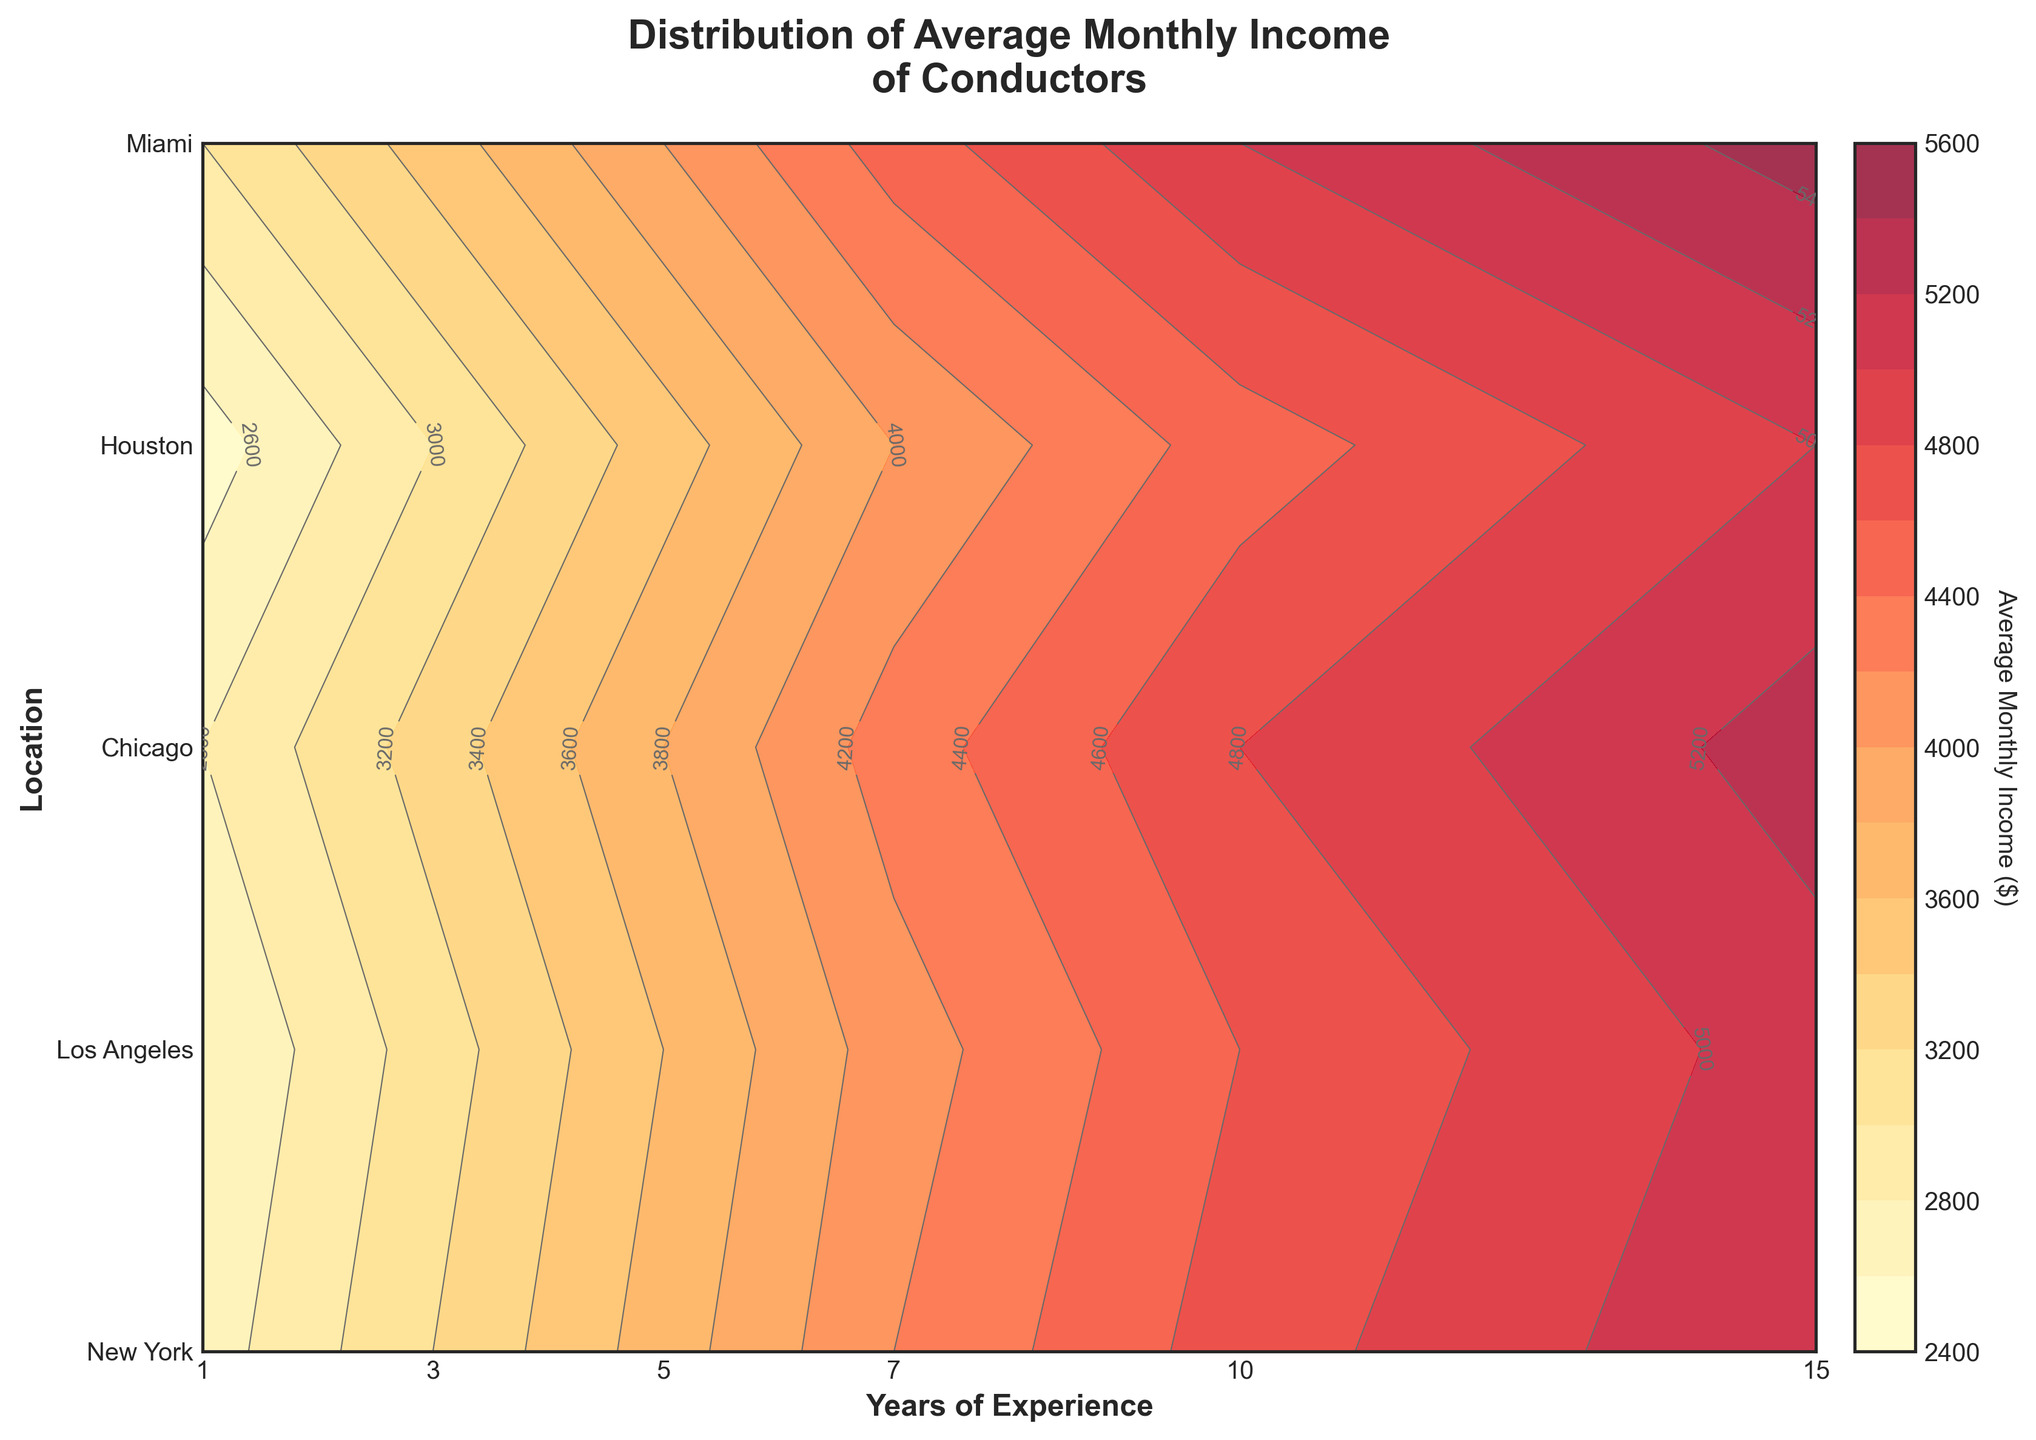What's the title of the plot? The title of the plot is usually located at the top of the figure and contains the main subject of the data being presented. This one is labeled "Distribution of Average Monthly Income of Conductors".
Answer: Distribution of Average Monthly Income of Conductors Which location has the highest average monthly income for conductors with 10 years of experience? From the figure, we can look at the contour labels for the 10-year mark and identify the highest income value among the locations listed. New York has the highest value at this level of experience.
Answer: New York What is the approximate average monthly income for conductors in Los Angeles with 7 years of experience? By locating 7 years of experience on the x-axis and Los Angeles on the y-axis, we can find the corresponding contour value which is labeled near the intersection. The contour label indicates approximately $4300.
Answer: $4300 How does the average income of conductors in Miami change from 1 year to 15 years of experience? We can follow the contour lines for Miami from 1 year to 15 years of experience. At 1 year, the income is $2500, and at 15 years, it is $5000. Therefore, the increase is $2500 ($5000 - $2500).
Answer: It increases by $2500 Which geographic location shows the steepest increase in average monthly income over the years of experience? The steepness of the increase can be judged by the density of contour lines. In locations with closer lines, the value changes more rapidly. New York has closely spaced contour lines, indicating a steep increase in income with years of experience.
Answer: New York What is the average monthly income of conductors in Houston with 5 years of experience? To find this, locate 5 years on the x-axis and Houston on the y-axis. The contour at this point is labeled as having a value of approximately $3600.
Answer: $3600 Between Chicago and Houston, which location has a higher average monthly income for conductors with 3 years of experience? Locate 3 years of experience on the x-axis and follow the contour lines for both Chicago and Houston. Chicago's contour line at this point is approximately $3200 and Houston's is $3100. Therefore, Chicago is higher.
Answer: Chicago If a conductor moves from Los Angeles to New York with 7 years of experience, how much more can they expect to earn on average monthly? For Los Angeles at 7 years, the contour indicates $4300, and for New York, it shows $4500. The difference is $4500 - $4300 = $200.
Answer: $200 What are the minimum and maximum average monthly incomes shown in the figure? The contour plot ranges from the minimum average monthly income at about $2500 (Miami, 1 year of experience) to the maximum at $5500 (New York, 15 years of experience).
Answer: $2500 and $5500 How does the count of contour levels help interpret the income distribution? The count of contour levels (15 in this plot) allows for a detailed and smooth representation of income changes over years of experience and between locations. This granularity helps to clearly identify income trends and differences.
Answer: They provide detailed granularity for income changes 